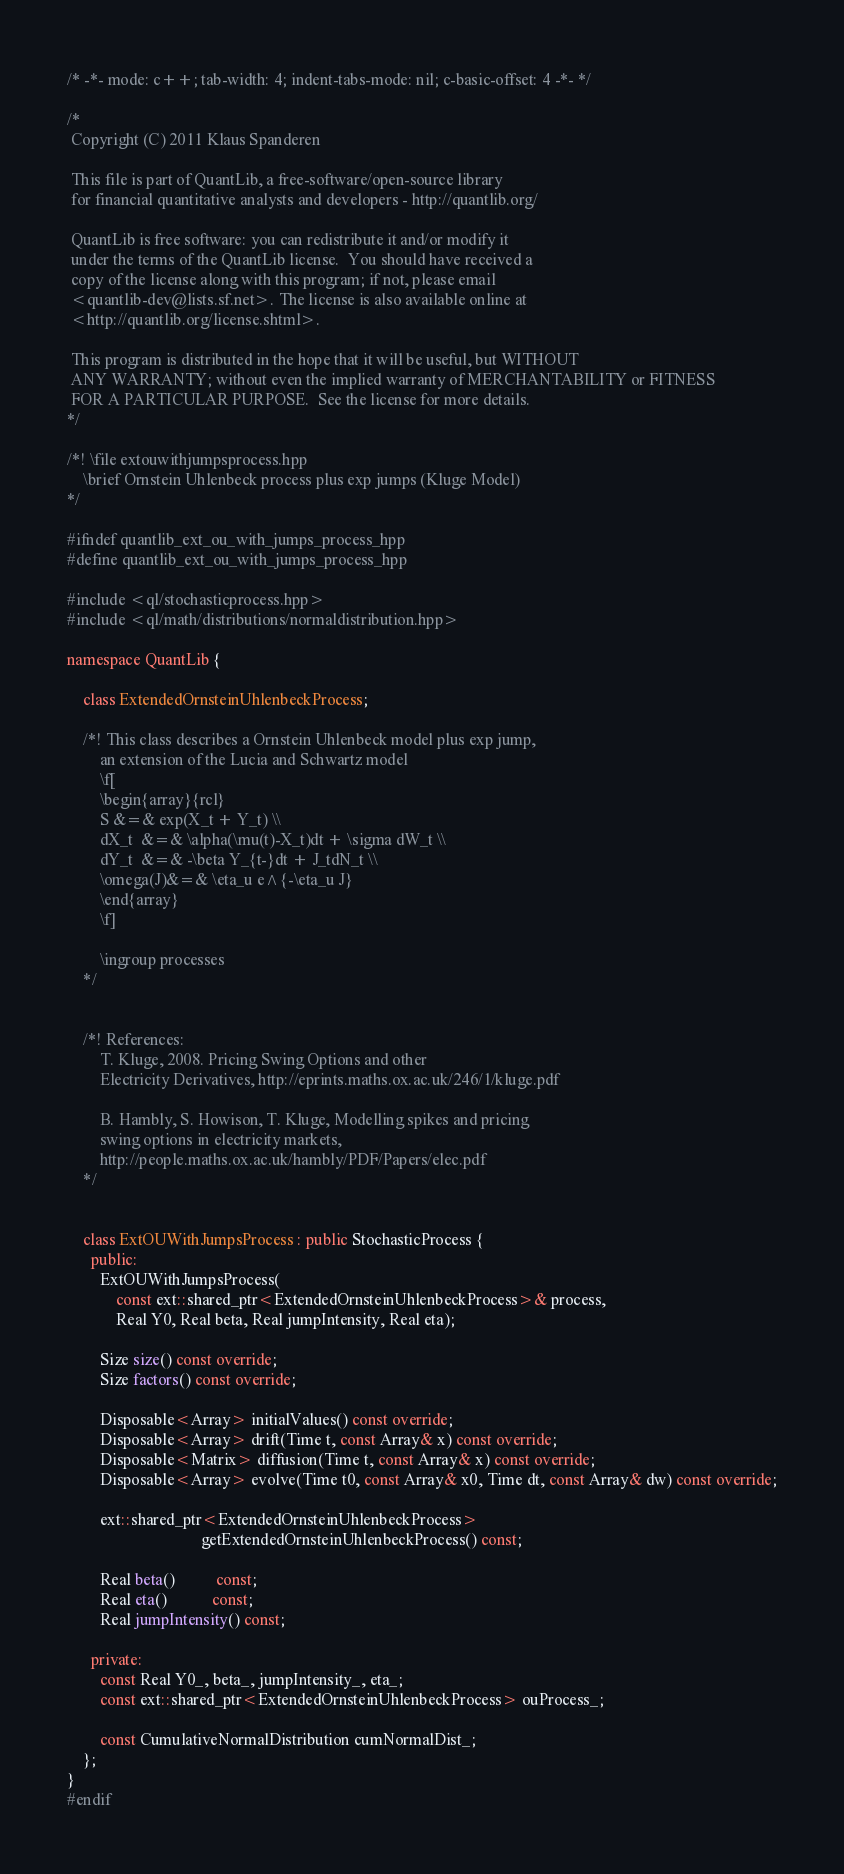Convert code to text. <code><loc_0><loc_0><loc_500><loc_500><_C++_>/* -*- mode: c++; tab-width: 4; indent-tabs-mode: nil; c-basic-offset: 4 -*- */

/*
 Copyright (C) 2011 Klaus Spanderen
 
 This file is part of QuantLib, a free-software/open-source library
 for financial quantitative analysts and developers - http://quantlib.org/

 QuantLib is free software: you can redistribute it and/or modify it
 under the terms of the QuantLib license.  You should have received a
 copy of the license along with this program; if not, please email
 <quantlib-dev@lists.sf.net>. The license is also available online at
 <http://quantlib.org/license.shtml>.

 This program is distributed in the hope that it will be useful, but WITHOUT
 ANY WARRANTY; without even the implied warranty of MERCHANTABILITY or FITNESS
 FOR A PARTICULAR PURPOSE.  See the license for more details.
*/

/*! \file extouwithjumpsprocess.hpp
    \brief Ornstein Uhlenbeck process plus exp jumps (Kluge Model)
*/

#ifndef quantlib_ext_ou_with_jumps_process_hpp
#define quantlib_ext_ou_with_jumps_process_hpp

#include <ql/stochasticprocess.hpp>
#include <ql/math/distributions/normaldistribution.hpp>

namespace QuantLib {

    class ExtendedOrnsteinUhlenbeckProcess;

    /*! This class describes a Ornstein Uhlenbeck model plus exp jump, 
        an extension of the Lucia and Schwartz model
        \f[
        \begin{array}{rcl}
        S &=& exp(X_t + Y_t) \\
        dX_t  &=& \alpha(\mu(t)-X_t)dt + \sigma dW_t \\
        dY_t  &=& -\beta Y_{t-}dt + J_tdN_t \\
        \omega(J)&=& \eta_u e^{-\eta_u J}
        \end{array}
        \f]
        
        \ingroup processes
    */


    /*! References:
        T. Kluge, 2008. Pricing Swing Options and other 
        Electricity Derivatives, http://eprints.maths.ox.ac.uk/246/1/kluge.pdf
        
        B. Hambly, S. Howison, T. Kluge, Modelling spikes and pricing 
        swing options in electricity markets,
        http://people.maths.ox.ac.uk/hambly/PDF/Papers/elec.pdf
    */
        

    class ExtOUWithJumpsProcess : public StochasticProcess {
      public:
        ExtOUWithJumpsProcess(
            const ext::shared_ptr<ExtendedOrnsteinUhlenbeckProcess>& process,
            Real Y0, Real beta, Real jumpIntensity, Real eta);

        Size size() const override;
        Size factors() const override;

        Disposable<Array> initialValues() const override;
        Disposable<Array> drift(Time t, const Array& x) const override;
        Disposable<Matrix> diffusion(Time t, const Array& x) const override;
        Disposable<Array> evolve(Time t0, const Array& x0, Time dt, const Array& dw) const override;

        ext::shared_ptr<ExtendedOrnsteinUhlenbeckProcess>
                                 getExtendedOrnsteinUhlenbeckProcess() const;

        Real beta()          const;
        Real eta()           const;
        Real jumpIntensity() const;

      private:
        const Real Y0_, beta_, jumpIntensity_, eta_;
        const ext::shared_ptr<ExtendedOrnsteinUhlenbeckProcess> ouProcess_;
        
        const CumulativeNormalDistribution cumNormalDist_;
    };
}
#endif
</code> 